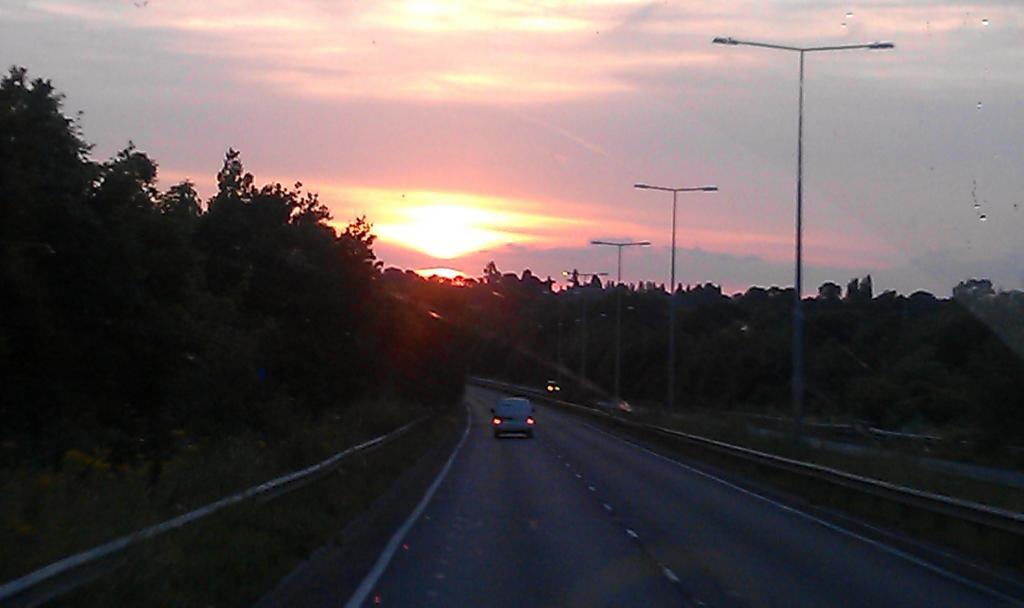What is on the road in the image? There is a vehicle on the road in the image. What type of natural elements can be seen in the image? There are trees visible in the image. What are the lights on poles used for? The lights on poles are likely used for illumination. What is visible in the background of the image? The sky is visible in the image. What can be observed in the sky? Clouds are present in the sky. What type of breakfast is being served in the image? There is no breakfast present in the image; it features a vehicle on the road, trees, lights on poles, the sky, and clouds. 